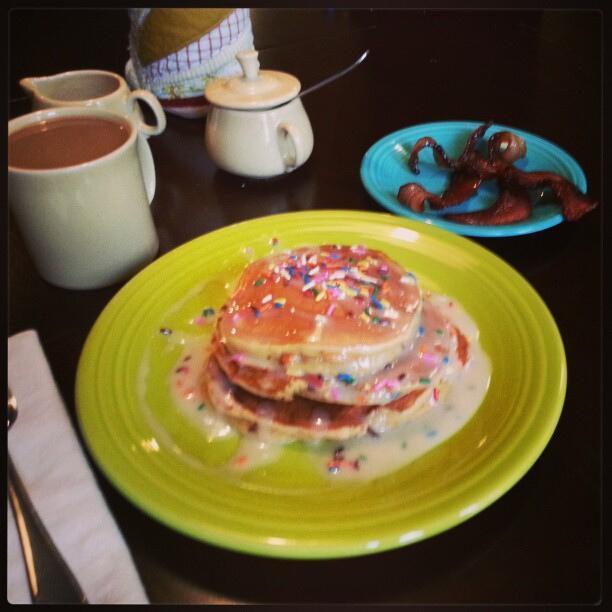How many plates are on the table?
Give a very brief answer. 2. How many candles are present?
Give a very brief answer. 0. How many cups are in the photo?
Give a very brief answer. 2. How many people are posing?
Give a very brief answer. 0. 